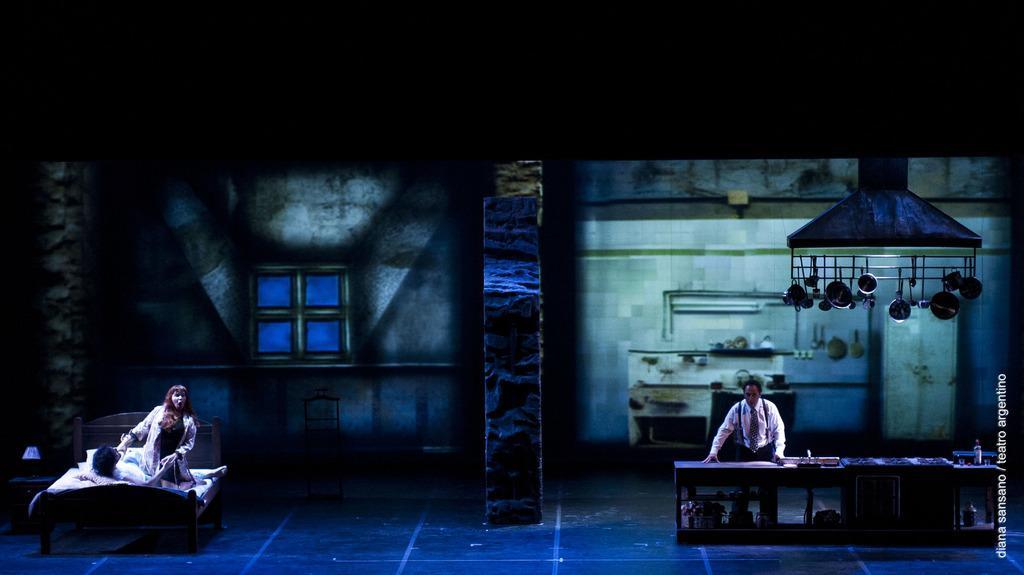How would you summarize this image in a sentence or two? In the picture we can see a dark room with a person standing near the table and working something and in the other room we can see some person lying on the bed and one girl sitting beside him holding the hands of the person. 